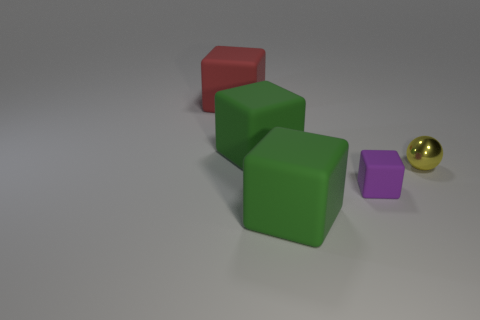Subtract 1 blocks. How many blocks are left? 3 Add 5 small yellow balls. How many objects exist? 10 Subtract all blocks. How many objects are left? 1 Add 2 red objects. How many red objects are left? 3 Add 5 big green blocks. How many big green blocks exist? 7 Subtract 0 blue cubes. How many objects are left? 5 Subtract all big red blocks. Subtract all large matte blocks. How many objects are left? 1 